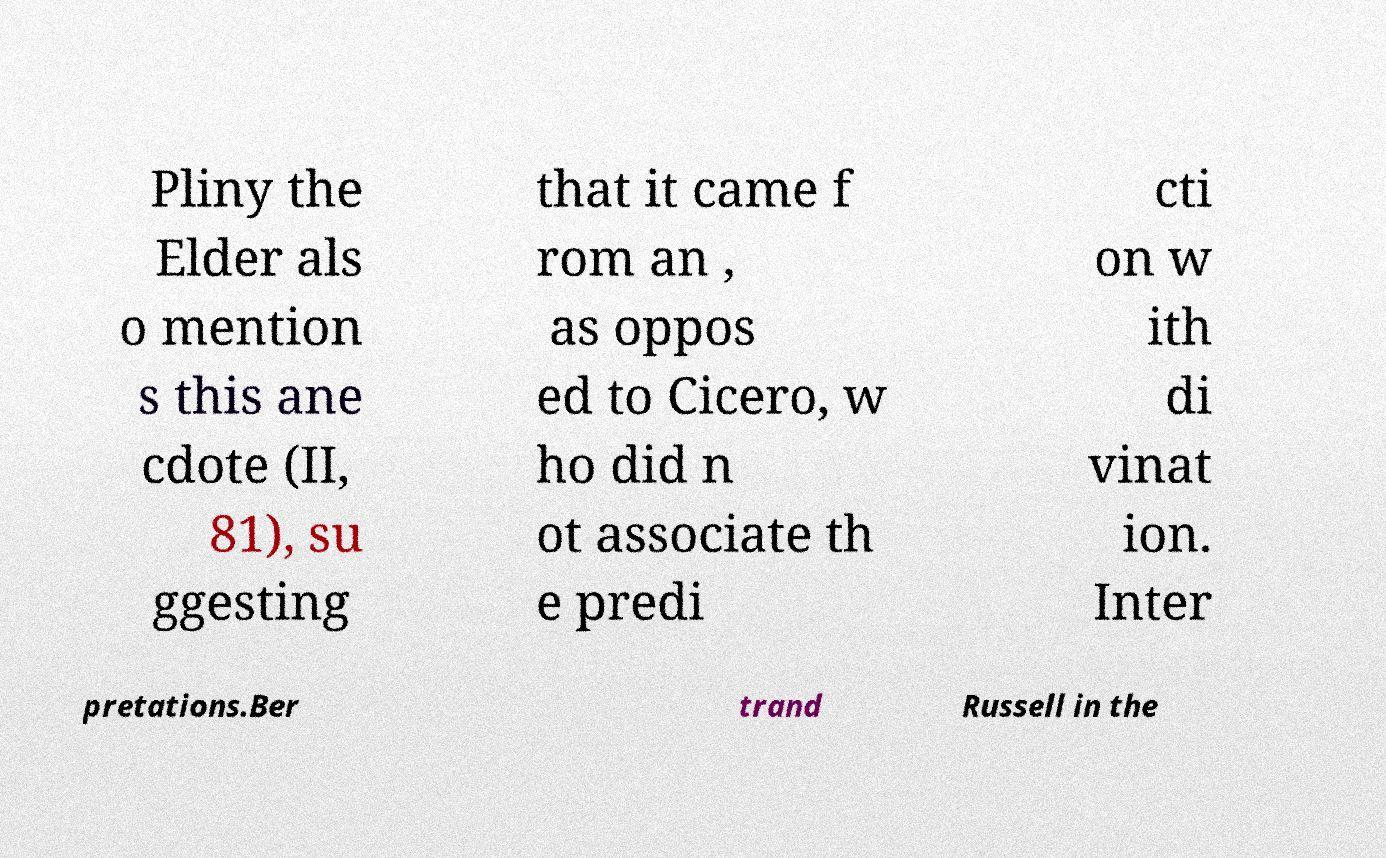There's text embedded in this image that I need extracted. Can you transcribe it verbatim? Pliny the Elder als o mention s this ane cdote (II, 81), su ggesting that it came f rom an , as oppos ed to Cicero, w ho did n ot associate th e predi cti on w ith di vinat ion. Inter pretations.Ber trand Russell in the 